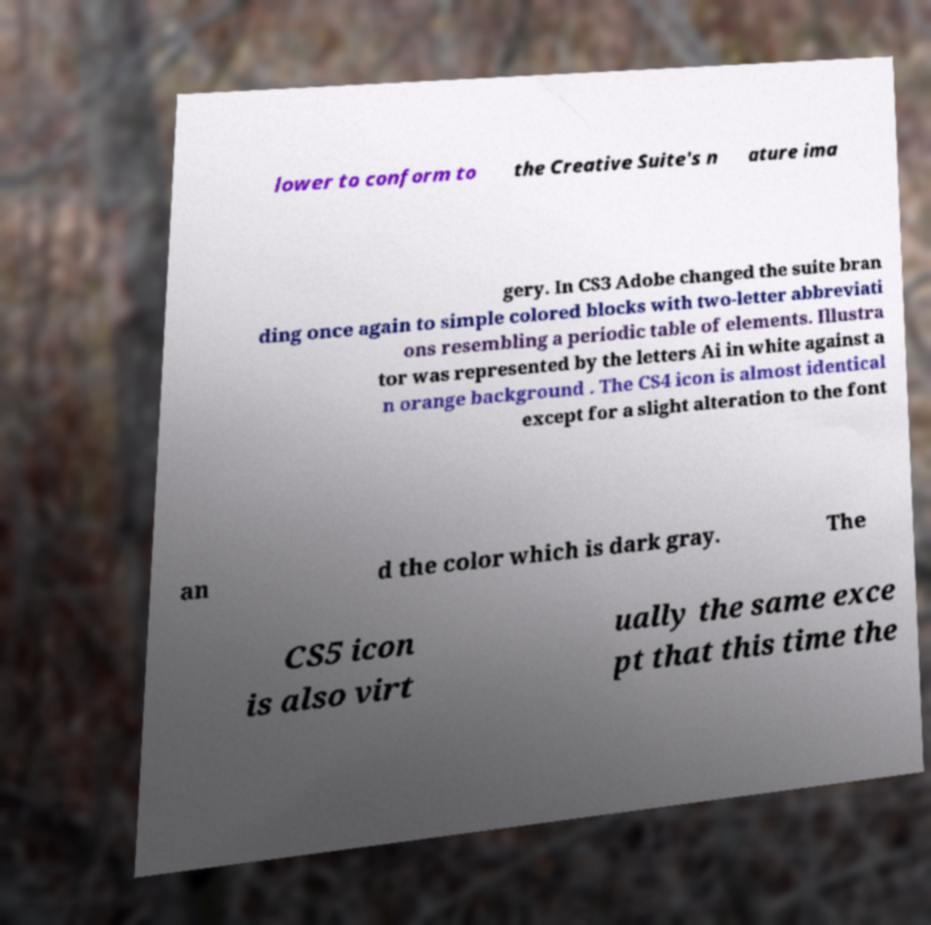I need the written content from this picture converted into text. Can you do that? lower to conform to the Creative Suite's n ature ima gery. In CS3 Adobe changed the suite bran ding once again to simple colored blocks with two-letter abbreviati ons resembling a periodic table of elements. Illustra tor was represented by the letters Ai in white against a n orange background . The CS4 icon is almost identical except for a slight alteration to the font an d the color which is dark gray. The CS5 icon is also virt ually the same exce pt that this time the 